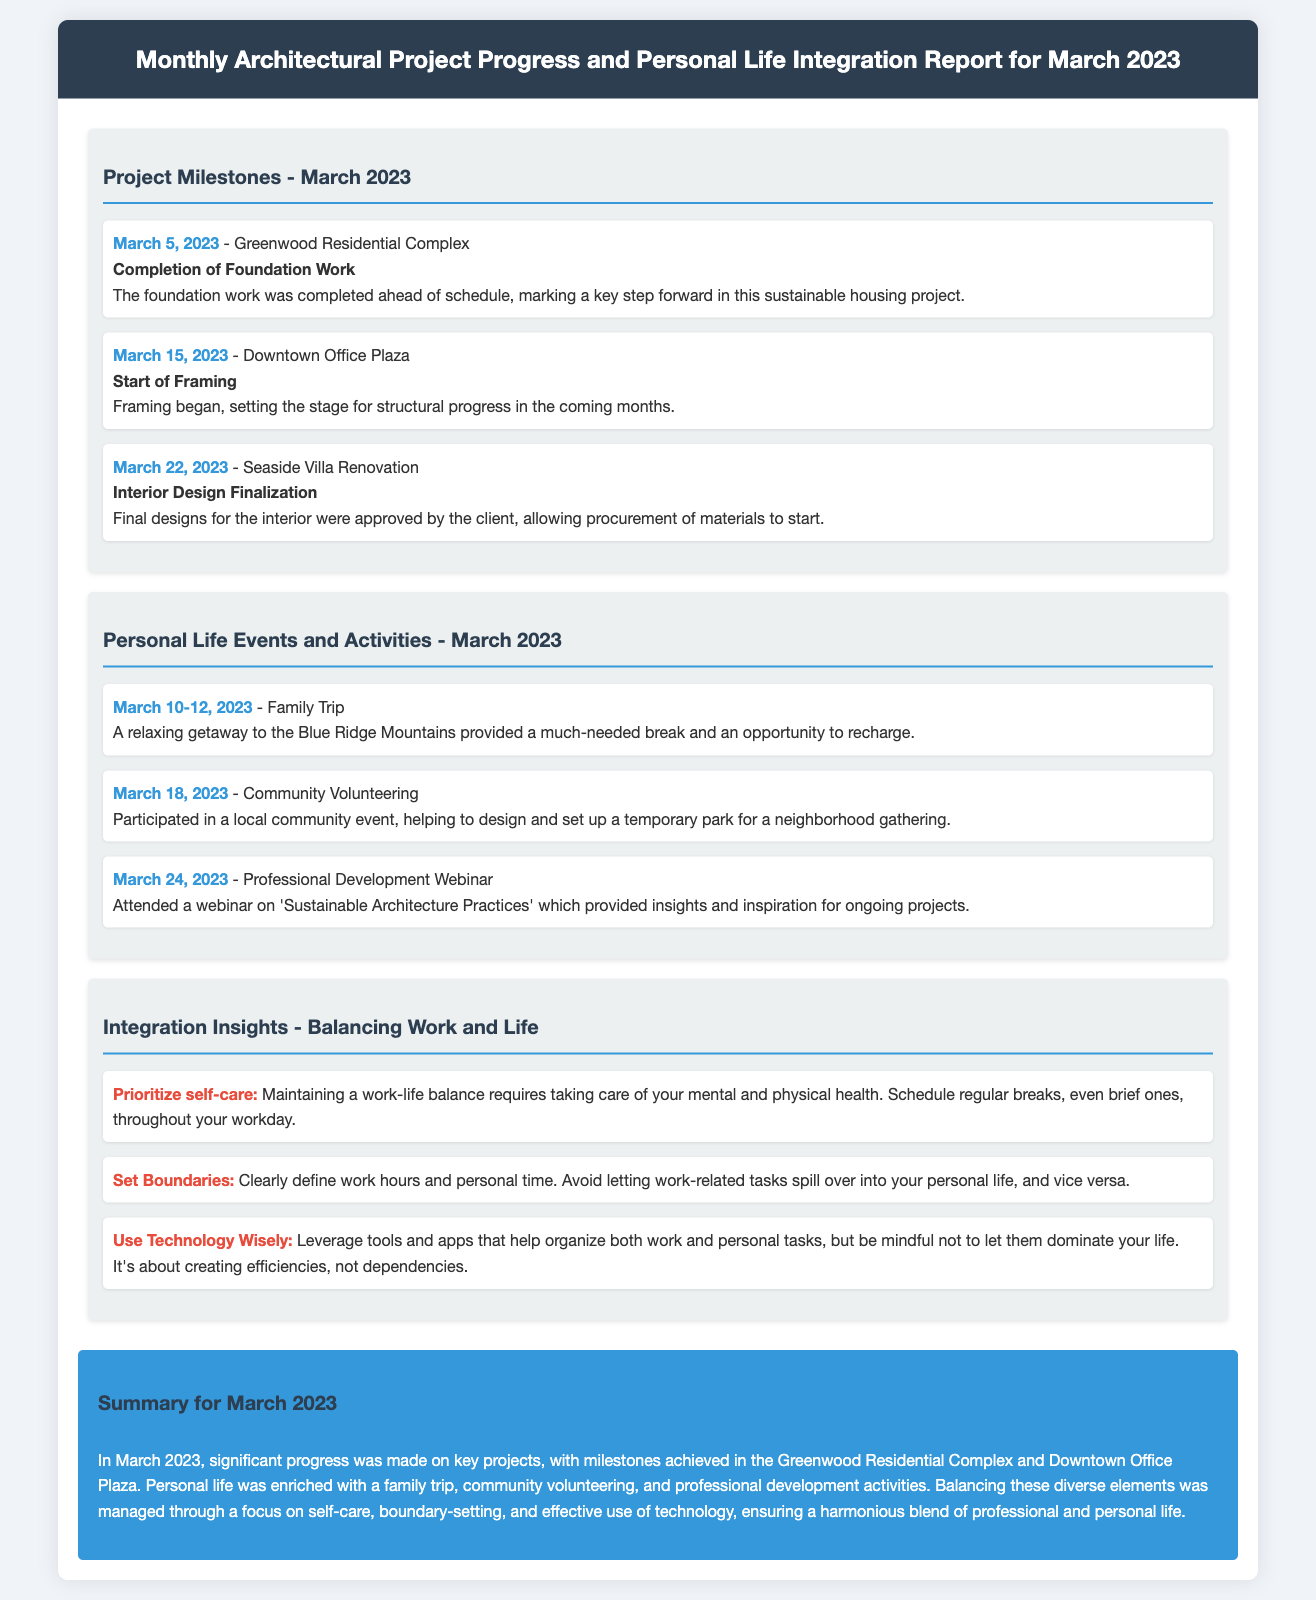What was completed ahead of schedule for the Greenwood Residential Complex? The document states that the foundation work was completed ahead of schedule.
Answer: Foundation Work When did the start of framing occur for the Downtown Office Plaza? According to the document, framing started on March 15, 2023.
Answer: March 15, 2023 What activity took place from March 10 to 12, 2023? The document mentions that a family trip occurred during these dates.
Answer: Family Trip Which event involved helping to design a temporary park? The community volunteering event is described as helping to design a temporary park.
Answer: Community Volunteering How many milestones were listed for projects in March 2023? The document lists three project milestones for March 2023.
Answer: Three What type of webinar did the participant attend on March 24, 2023? The document specifies that the webinar was on 'Sustainable Architecture Practices.'
Answer: Sustainable Architecture Practices What is one tip mentioned for maintaining work-life balance? One of the tips provided is to prioritize self-care.
Answer: Prioritize self-care How many personal life events are listed in the summary? The summary refers to three personal life events.
Answer: Three 